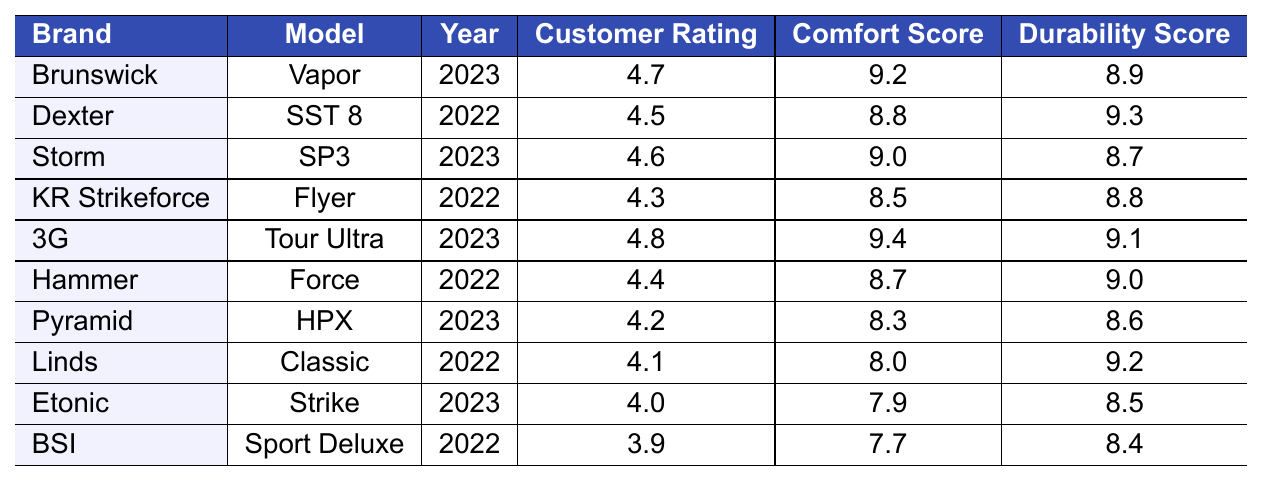What is the customer rating for the 3G Tour Ultra shoes? From the table, we can see that the customer rating for the 3G Tour Ultra model is located in the row for that model, which is 4.8.
Answer: 4.8 Which brand has the highest durability score? To find the highest durability score, look for the maximum value in the Durability Score column. The highest score of 9.3 belongs to the Dexter SST 8 model.
Answer: Dexter What is the difference in customer ratings between the highest-rated and the lowest-rated shoes? The highest customer rating is 4.8 for the 3G Tour Ultra, and the lowest is 3.9 for the BSI Sport Deluxe. The difference is 4.8 - 3.9 = 0.9.
Answer: 0.9 Are there any bowling shoe brands with a customer rating above 4.5? By reviewing the Customer Rating column, we can identify the brands with ratings above 4.5: Brunswick (4.7), Storm (4.6), and 3G (4.8), indicating that yes, there are brands above this threshold.
Answer: Yes What is the average comfort score of the shoes listed in the table? To calculate the average, sum the comfort scores: 9.2 + 8.8 + 9.0 + 8.5 + 9.4 + 8.7 + 8.3 + 8.0 + 7.9 + 7.7 = 88.5. There are 10 entries, so the average is 88.5 / 10 = 8.85.
Answer: 8.85 Is there a shoe from the year 2022 that has a customer rating higher than 4.3? Looking at the table, the only brand from 2022 with a rating higher than 4.3 is Dexter with a rating of 4.5. Thus, the answer is yes.
Answer: Yes What brand has a comfort score closest to 8.5? Reviewing the Comfort Score column, Hammer (8.7) has the closest score at 8.7 compared to 8.5, making it the nearest brand.
Answer: Hammer How many models have customer ratings of 4.0 or below? Checking the Customer Rating column, we find three models with ratings of 4.0 or below: Pyramid (4.2), Etonic (4.0), and BSI (3.9). Thus, the count is 3.
Answer: 3 If you average the durability scores of the top three rated shoes, what do you get? Identify the top three rated shoes: 3G (9.1), Brunswick (8.9), and Storm (8.7). Their durability scores are 9.1, 8.9, and 8.7, which sum to 26.7. The average is 26.7 / 3 = 8.9.
Answer: 8.9 Are the comfort scores of the 2023 models generally higher than the scores of the 2022 models? The comfort scores for 2023 models are 9.2 (Brunswick), 9.0 (Storm), 9.4 (3G), and 8.3 (Pyramid), averaging 8.975. For 2022 models, the scores are 8.8 (Dexter), 8.5 (KR Strikeforce), 8.7 (Hammer), 8.0 (Linds), and 7.7 (BSI), averaging 8.54. Since 8.975 > 8.54, the answer is yes.
Answer: Yes 